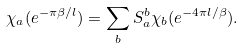<formula> <loc_0><loc_0><loc_500><loc_500>\chi _ { a } ( e ^ { - \pi \beta / l } ) = \sum _ { b } S ^ { b } _ { a } \chi _ { b } ( e ^ { - 4 \pi l / \beta } ) .</formula> 